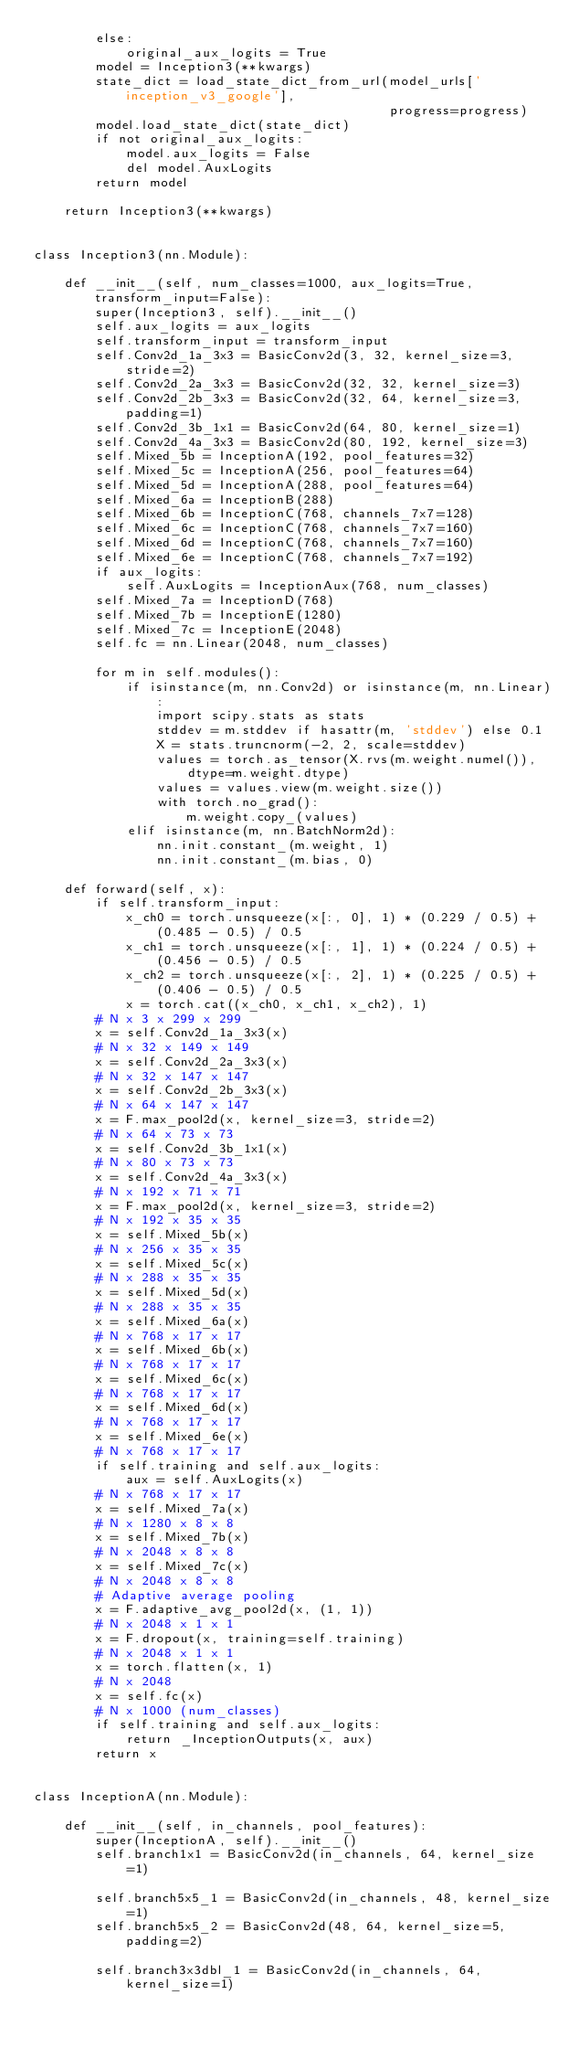<code> <loc_0><loc_0><loc_500><loc_500><_Python_>        else:
            original_aux_logits = True
        model = Inception3(**kwargs)
        state_dict = load_state_dict_from_url(model_urls['inception_v3_google'],
                                              progress=progress)
        model.load_state_dict(state_dict)
        if not original_aux_logits:
            model.aux_logits = False
            del model.AuxLogits
        return model

    return Inception3(**kwargs)


class Inception3(nn.Module):

    def __init__(self, num_classes=1000, aux_logits=True, transform_input=False):
        super(Inception3, self).__init__()
        self.aux_logits = aux_logits
        self.transform_input = transform_input
        self.Conv2d_1a_3x3 = BasicConv2d(3, 32, kernel_size=3, stride=2)
        self.Conv2d_2a_3x3 = BasicConv2d(32, 32, kernel_size=3)
        self.Conv2d_2b_3x3 = BasicConv2d(32, 64, kernel_size=3, padding=1)
        self.Conv2d_3b_1x1 = BasicConv2d(64, 80, kernel_size=1)
        self.Conv2d_4a_3x3 = BasicConv2d(80, 192, kernel_size=3)
        self.Mixed_5b = InceptionA(192, pool_features=32)
        self.Mixed_5c = InceptionA(256, pool_features=64)
        self.Mixed_5d = InceptionA(288, pool_features=64)
        self.Mixed_6a = InceptionB(288)
        self.Mixed_6b = InceptionC(768, channels_7x7=128)
        self.Mixed_6c = InceptionC(768, channels_7x7=160)
        self.Mixed_6d = InceptionC(768, channels_7x7=160)
        self.Mixed_6e = InceptionC(768, channels_7x7=192)
        if aux_logits:
            self.AuxLogits = InceptionAux(768, num_classes)
        self.Mixed_7a = InceptionD(768)
        self.Mixed_7b = InceptionE(1280)
        self.Mixed_7c = InceptionE(2048)
        self.fc = nn.Linear(2048, num_classes)

        for m in self.modules():
            if isinstance(m, nn.Conv2d) or isinstance(m, nn.Linear):
                import scipy.stats as stats
                stddev = m.stddev if hasattr(m, 'stddev') else 0.1
                X = stats.truncnorm(-2, 2, scale=stddev)
                values = torch.as_tensor(X.rvs(m.weight.numel()), dtype=m.weight.dtype)
                values = values.view(m.weight.size())
                with torch.no_grad():
                    m.weight.copy_(values)
            elif isinstance(m, nn.BatchNorm2d):
                nn.init.constant_(m.weight, 1)
                nn.init.constant_(m.bias, 0)

    def forward(self, x):
        if self.transform_input:
            x_ch0 = torch.unsqueeze(x[:, 0], 1) * (0.229 / 0.5) + (0.485 - 0.5) / 0.5
            x_ch1 = torch.unsqueeze(x[:, 1], 1) * (0.224 / 0.5) + (0.456 - 0.5) / 0.5
            x_ch2 = torch.unsqueeze(x[:, 2], 1) * (0.225 / 0.5) + (0.406 - 0.5) / 0.5
            x = torch.cat((x_ch0, x_ch1, x_ch2), 1)
        # N x 3 x 299 x 299
        x = self.Conv2d_1a_3x3(x)
        # N x 32 x 149 x 149
        x = self.Conv2d_2a_3x3(x)
        # N x 32 x 147 x 147
        x = self.Conv2d_2b_3x3(x)
        # N x 64 x 147 x 147
        x = F.max_pool2d(x, kernel_size=3, stride=2)
        # N x 64 x 73 x 73
        x = self.Conv2d_3b_1x1(x)
        # N x 80 x 73 x 73
        x = self.Conv2d_4a_3x3(x)
        # N x 192 x 71 x 71
        x = F.max_pool2d(x, kernel_size=3, stride=2)
        # N x 192 x 35 x 35
        x = self.Mixed_5b(x)
        # N x 256 x 35 x 35
        x = self.Mixed_5c(x)
        # N x 288 x 35 x 35
        x = self.Mixed_5d(x)
        # N x 288 x 35 x 35
        x = self.Mixed_6a(x)
        # N x 768 x 17 x 17
        x = self.Mixed_6b(x)
        # N x 768 x 17 x 17
        x = self.Mixed_6c(x)
        # N x 768 x 17 x 17
        x = self.Mixed_6d(x)
        # N x 768 x 17 x 17
        x = self.Mixed_6e(x)
        # N x 768 x 17 x 17
        if self.training and self.aux_logits:
            aux = self.AuxLogits(x)
        # N x 768 x 17 x 17
        x = self.Mixed_7a(x)
        # N x 1280 x 8 x 8
        x = self.Mixed_7b(x)
        # N x 2048 x 8 x 8
        x = self.Mixed_7c(x)
        # N x 2048 x 8 x 8
        # Adaptive average pooling
        x = F.adaptive_avg_pool2d(x, (1, 1))
        # N x 2048 x 1 x 1
        x = F.dropout(x, training=self.training)
        # N x 2048 x 1 x 1
        x = torch.flatten(x, 1)
        # N x 2048
        x = self.fc(x)
        # N x 1000 (num_classes)
        if self.training and self.aux_logits:
            return _InceptionOutputs(x, aux)
        return x


class InceptionA(nn.Module):

    def __init__(self, in_channels, pool_features):
        super(InceptionA, self).__init__()
        self.branch1x1 = BasicConv2d(in_channels, 64, kernel_size=1)

        self.branch5x5_1 = BasicConv2d(in_channels, 48, kernel_size=1)
        self.branch5x5_2 = BasicConv2d(48, 64, kernel_size=5, padding=2)

        self.branch3x3dbl_1 = BasicConv2d(in_channels, 64, kernel_size=1)</code> 